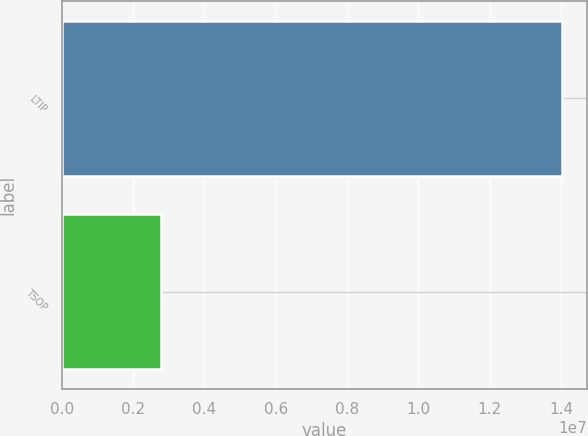Convert chart. <chart><loc_0><loc_0><loc_500><loc_500><bar_chart><fcel>LTIP<fcel>TSOP<nl><fcel>1.40331e+07<fcel>2.7733e+06<nl></chart> 